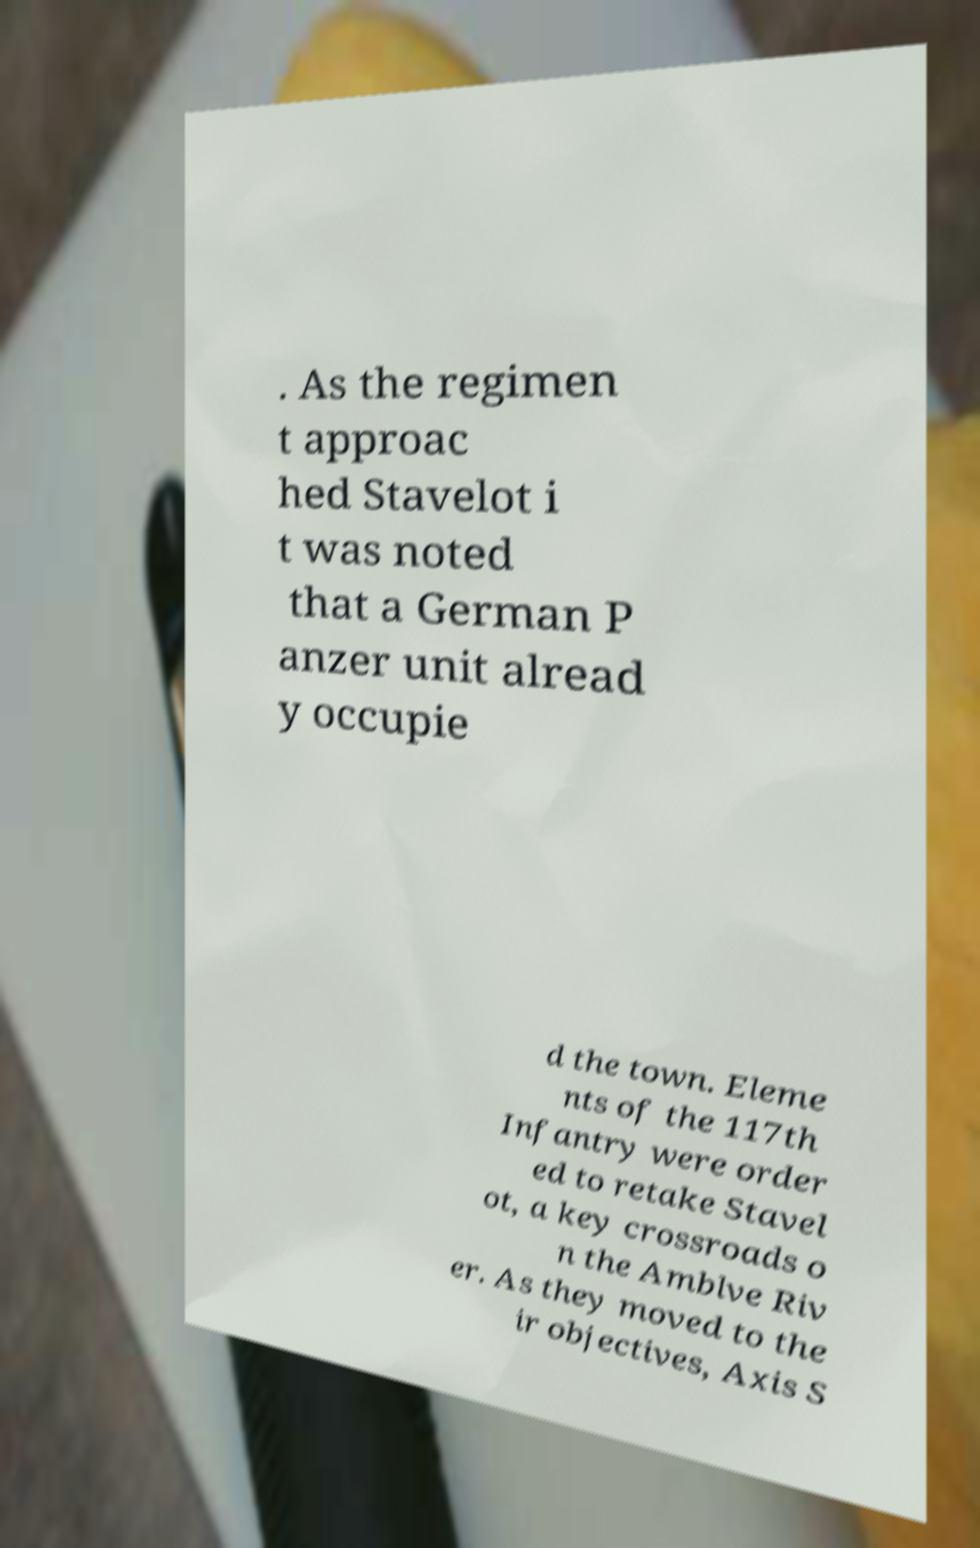Please read and relay the text visible in this image. What does it say? . As the regimen t approac hed Stavelot i t was noted that a German P anzer unit alread y occupie d the town. Eleme nts of the 117th Infantry were order ed to retake Stavel ot, a key crossroads o n the Amblve Riv er. As they moved to the ir objectives, Axis S 